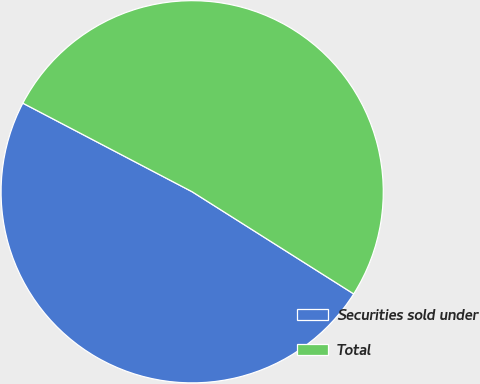Convert chart. <chart><loc_0><loc_0><loc_500><loc_500><pie_chart><fcel>Securities sold under<fcel>Total<nl><fcel>48.7%<fcel>51.3%<nl></chart> 